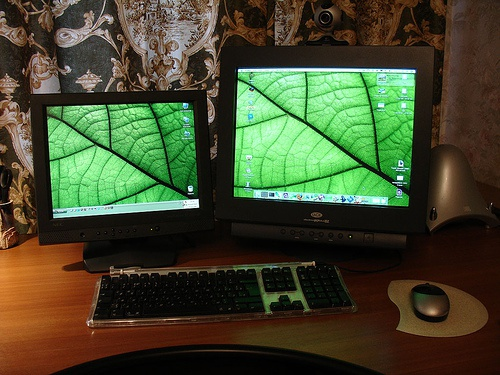Describe the objects in this image and their specific colors. I can see tv in black, lightgreen, and green tones, tv in black and lightgreen tones, keyboard in black, darkgreen, maroon, and gray tones, and mouse in black, maroon, and gray tones in this image. 